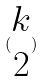Convert formula to latex. <formula><loc_0><loc_0><loc_500><loc_500>( \begin{matrix} k \\ 2 \end{matrix} )</formula> 